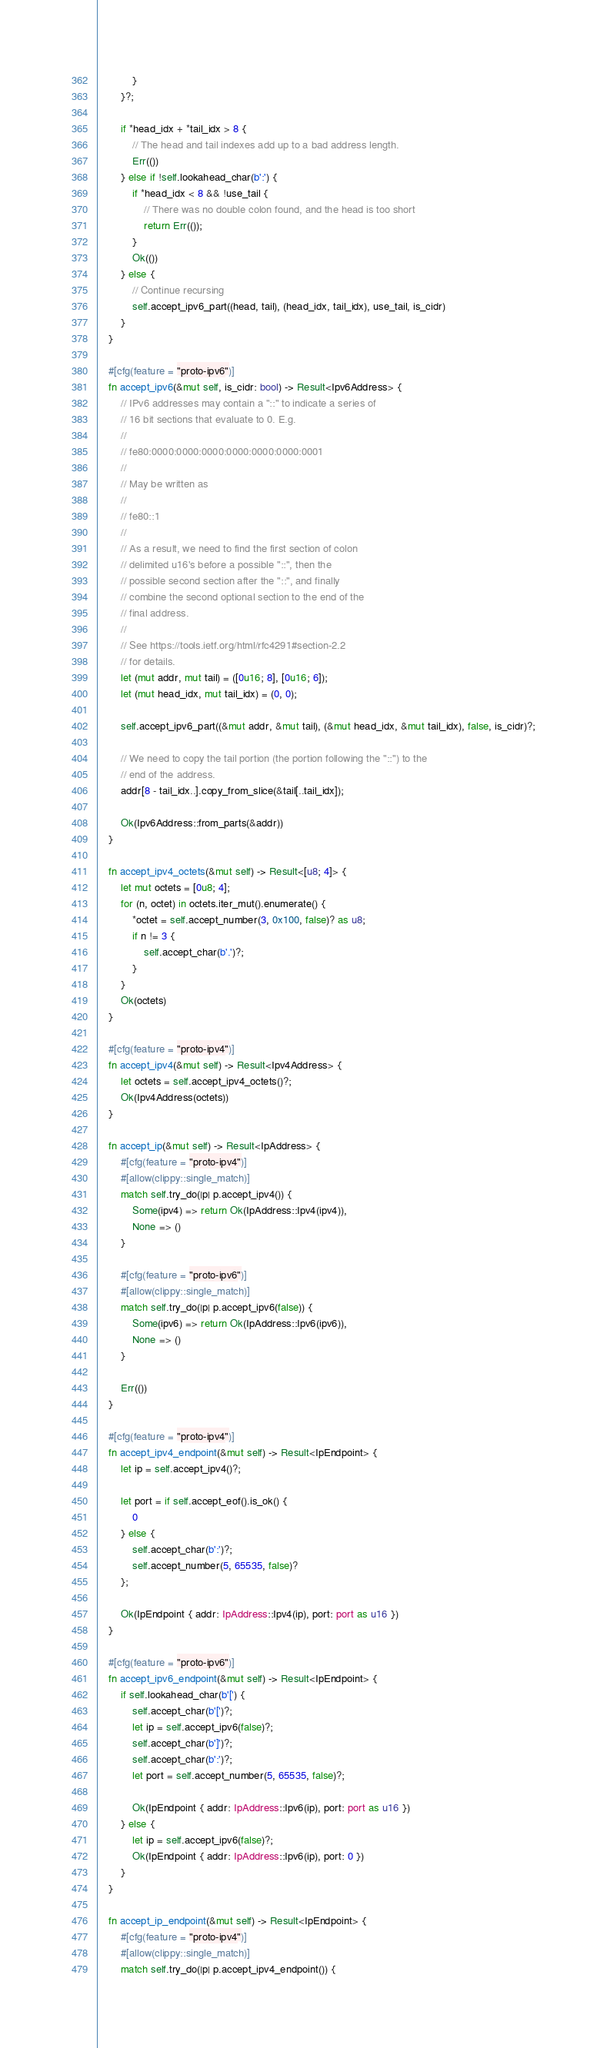<code> <loc_0><loc_0><loc_500><loc_500><_Rust_>            }
        }?;

        if *head_idx + *tail_idx > 8 {
            // The head and tail indexes add up to a bad address length.
            Err(())
        } else if !self.lookahead_char(b':') {
            if *head_idx < 8 && !use_tail {
                // There was no double colon found, and the head is too short
                return Err(());
            }
            Ok(())
        } else {
            // Continue recursing
            self.accept_ipv6_part((head, tail), (head_idx, tail_idx), use_tail, is_cidr)
        }
    }

    #[cfg(feature = "proto-ipv6")]
    fn accept_ipv6(&mut self, is_cidr: bool) -> Result<Ipv6Address> {
        // IPv6 addresses may contain a "::" to indicate a series of
        // 16 bit sections that evaluate to 0. E.g.
        //
        // fe80:0000:0000:0000:0000:0000:0000:0001
        //
        // May be written as
        //
        // fe80::1
        //
        // As a result, we need to find the first section of colon
        // delimited u16's before a possible "::", then the
        // possible second section after the "::", and finally
        // combine the second optional section to the end of the
        // final address.
        //
        // See https://tools.ietf.org/html/rfc4291#section-2.2
        // for details.
        let (mut addr, mut tail) = ([0u16; 8], [0u16; 6]);
        let (mut head_idx, mut tail_idx) = (0, 0);

        self.accept_ipv6_part((&mut addr, &mut tail), (&mut head_idx, &mut tail_idx), false, is_cidr)?;

        // We need to copy the tail portion (the portion following the "::") to the
        // end of the address.
        addr[8 - tail_idx..].copy_from_slice(&tail[..tail_idx]);

        Ok(Ipv6Address::from_parts(&addr))
    }

    fn accept_ipv4_octets(&mut self) -> Result<[u8; 4]> {
        let mut octets = [0u8; 4];
        for (n, octet) in octets.iter_mut().enumerate() {
            *octet = self.accept_number(3, 0x100, false)? as u8;
            if n != 3 {
                self.accept_char(b'.')?;
            }
        }
        Ok(octets)
    }

    #[cfg(feature = "proto-ipv4")]
    fn accept_ipv4(&mut self) -> Result<Ipv4Address> {
        let octets = self.accept_ipv4_octets()?;
        Ok(Ipv4Address(octets))
    }

    fn accept_ip(&mut self) -> Result<IpAddress> {
        #[cfg(feature = "proto-ipv4")]
        #[allow(clippy::single_match)]
        match self.try_do(|p| p.accept_ipv4()) {
            Some(ipv4) => return Ok(IpAddress::Ipv4(ipv4)),
            None => ()
        }

        #[cfg(feature = "proto-ipv6")]
        #[allow(clippy::single_match)]
        match self.try_do(|p| p.accept_ipv6(false)) {
            Some(ipv6) => return Ok(IpAddress::Ipv6(ipv6)),
            None => ()
        }

        Err(())
    }

    #[cfg(feature = "proto-ipv4")]
    fn accept_ipv4_endpoint(&mut self) -> Result<IpEndpoint> {
        let ip = self.accept_ipv4()?;

        let port = if self.accept_eof().is_ok() {
            0
        } else {
            self.accept_char(b':')?;
            self.accept_number(5, 65535, false)?
        };

        Ok(IpEndpoint { addr: IpAddress::Ipv4(ip), port: port as u16 })
    }

    #[cfg(feature = "proto-ipv6")]
    fn accept_ipv6_endpoint(&mut self) -> Result<IpEndpoint> {
        if self.lookahead_char(b'[') {
            self.accept_char(b'[')?;
            let ip = self.accept_ipv6(false)?;
            self.accept_char(b']')?;
            self.accept_char(b':')?;
            let port = self.accept_number(5, 65535, false)?;

            Ok(IpEndpoint { addr: IpAddress::Ipv6(ip), port: port as u16 })
        } else {
            let ip = self.accept_ipv6(false)?;
            Ok(IpEndpoint { addr: IpAddress::Ipv6(ip), port: 0 })
        }
    }

    fn accept_ip_endpoint(&mut self) -> Result<IpEndpoint> {
        #[cfg(feature = "proto-ipv4")]
        #[allow(clippy::single_match)]
        match self.try_do(|p| p.accept_ipv4_endpoint()) {</code> 